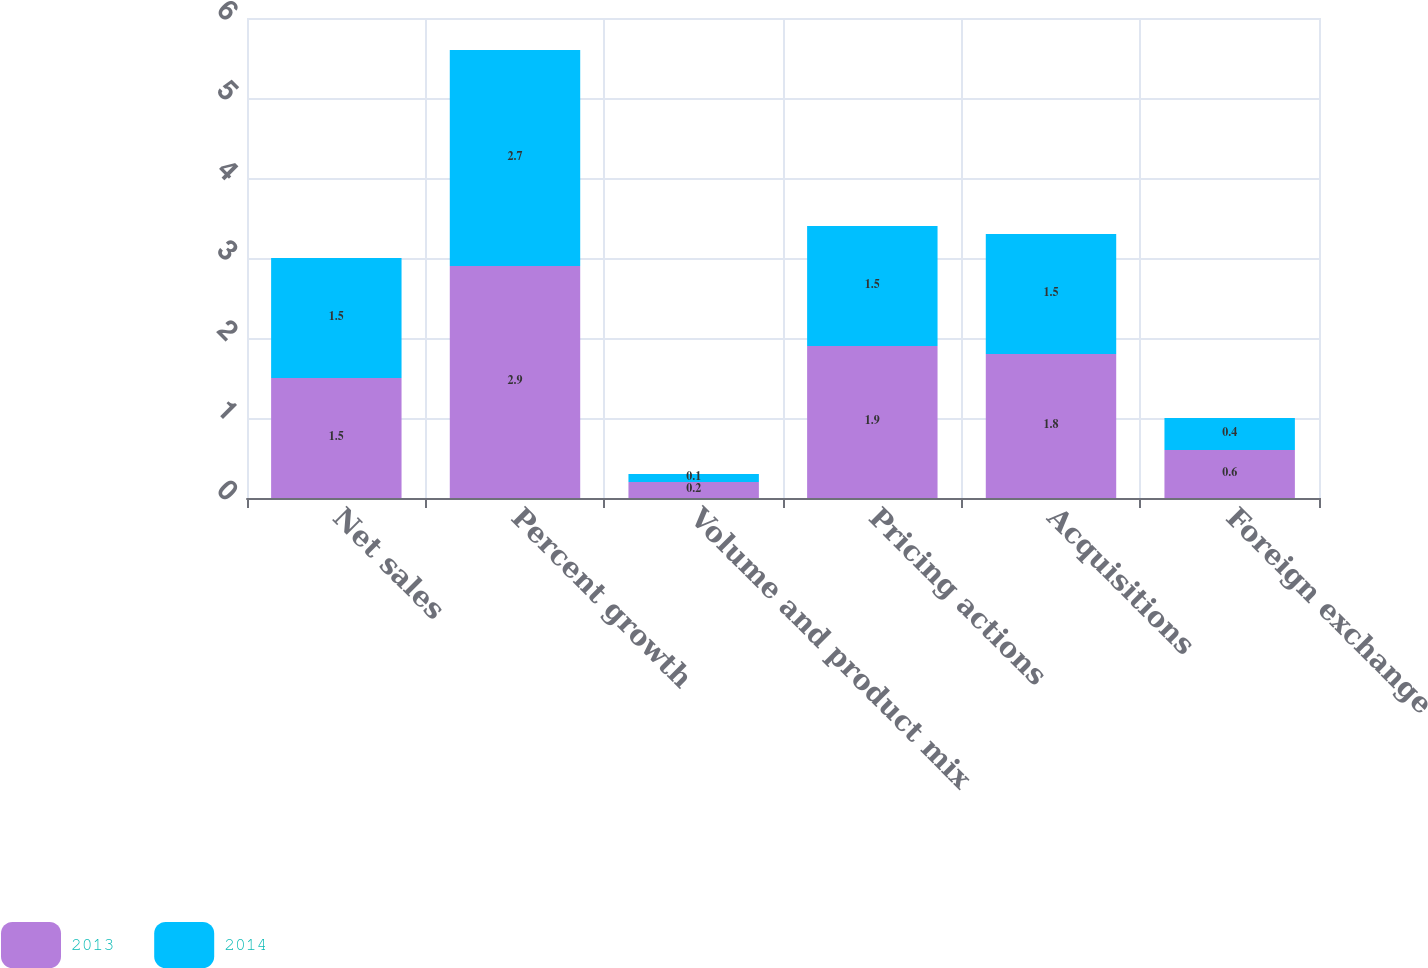Convert chart to OTSL. <chart><loc_0><loc_0><loc_500><loc_500><stacked_bar_chart><ecel><fcel>Net sales<fcel>Percent growth<fcel>Volume and product mix<fcel>Pricing actions<fcel>Acquisitions<fcel>Foreign exchange<nl><fcel>2013<fcel>1.5<fcel>2.9<fcel>0.2<fcel>1.9<fcel>1.8<fcel>0.6<nl><fcel>2014<fcel>1.5<fcel>2.7<fcel>0.1<fcel>1.5<fcel>1.5<fcel>0.4<nl></chart> 